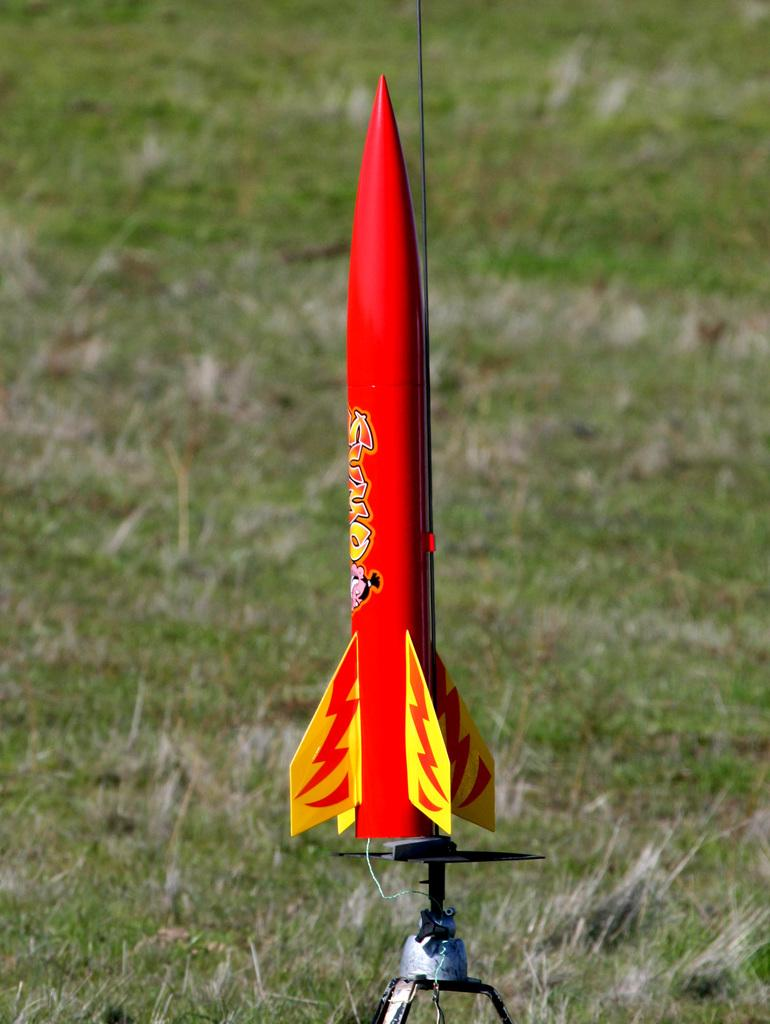What is the main object in the image? There is a toy rocket in the image. Where is the toy rocket located? The toy rocket is in the middle of a grassland. What type of yoke is attached to the toy rocket in the image? There is no yoke attached to the toy rocket in the image. What type of insurance is required for the toy rocket in the image? There is no need for insurance for a toy rocket, as it is not a real rocket. 